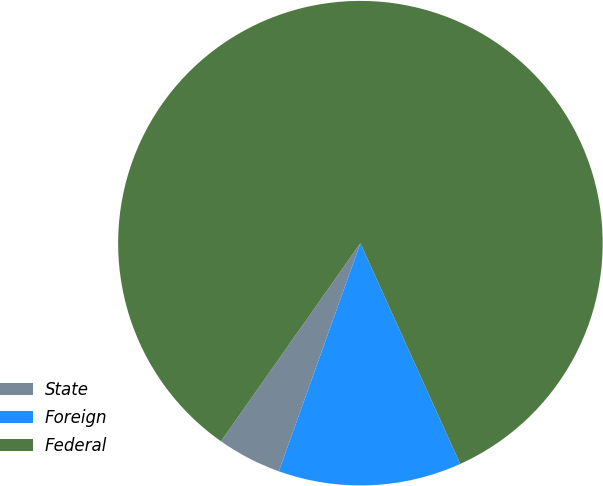Convert chart. <chart><loc_0><loc_0><loc_500><loc_500><pie_chart><fcel>State<fcel>Foreign<fcel>Federal<nl><fcel>4.3%<fcel>12.22%<fcel>83.48%<nl></chart> 